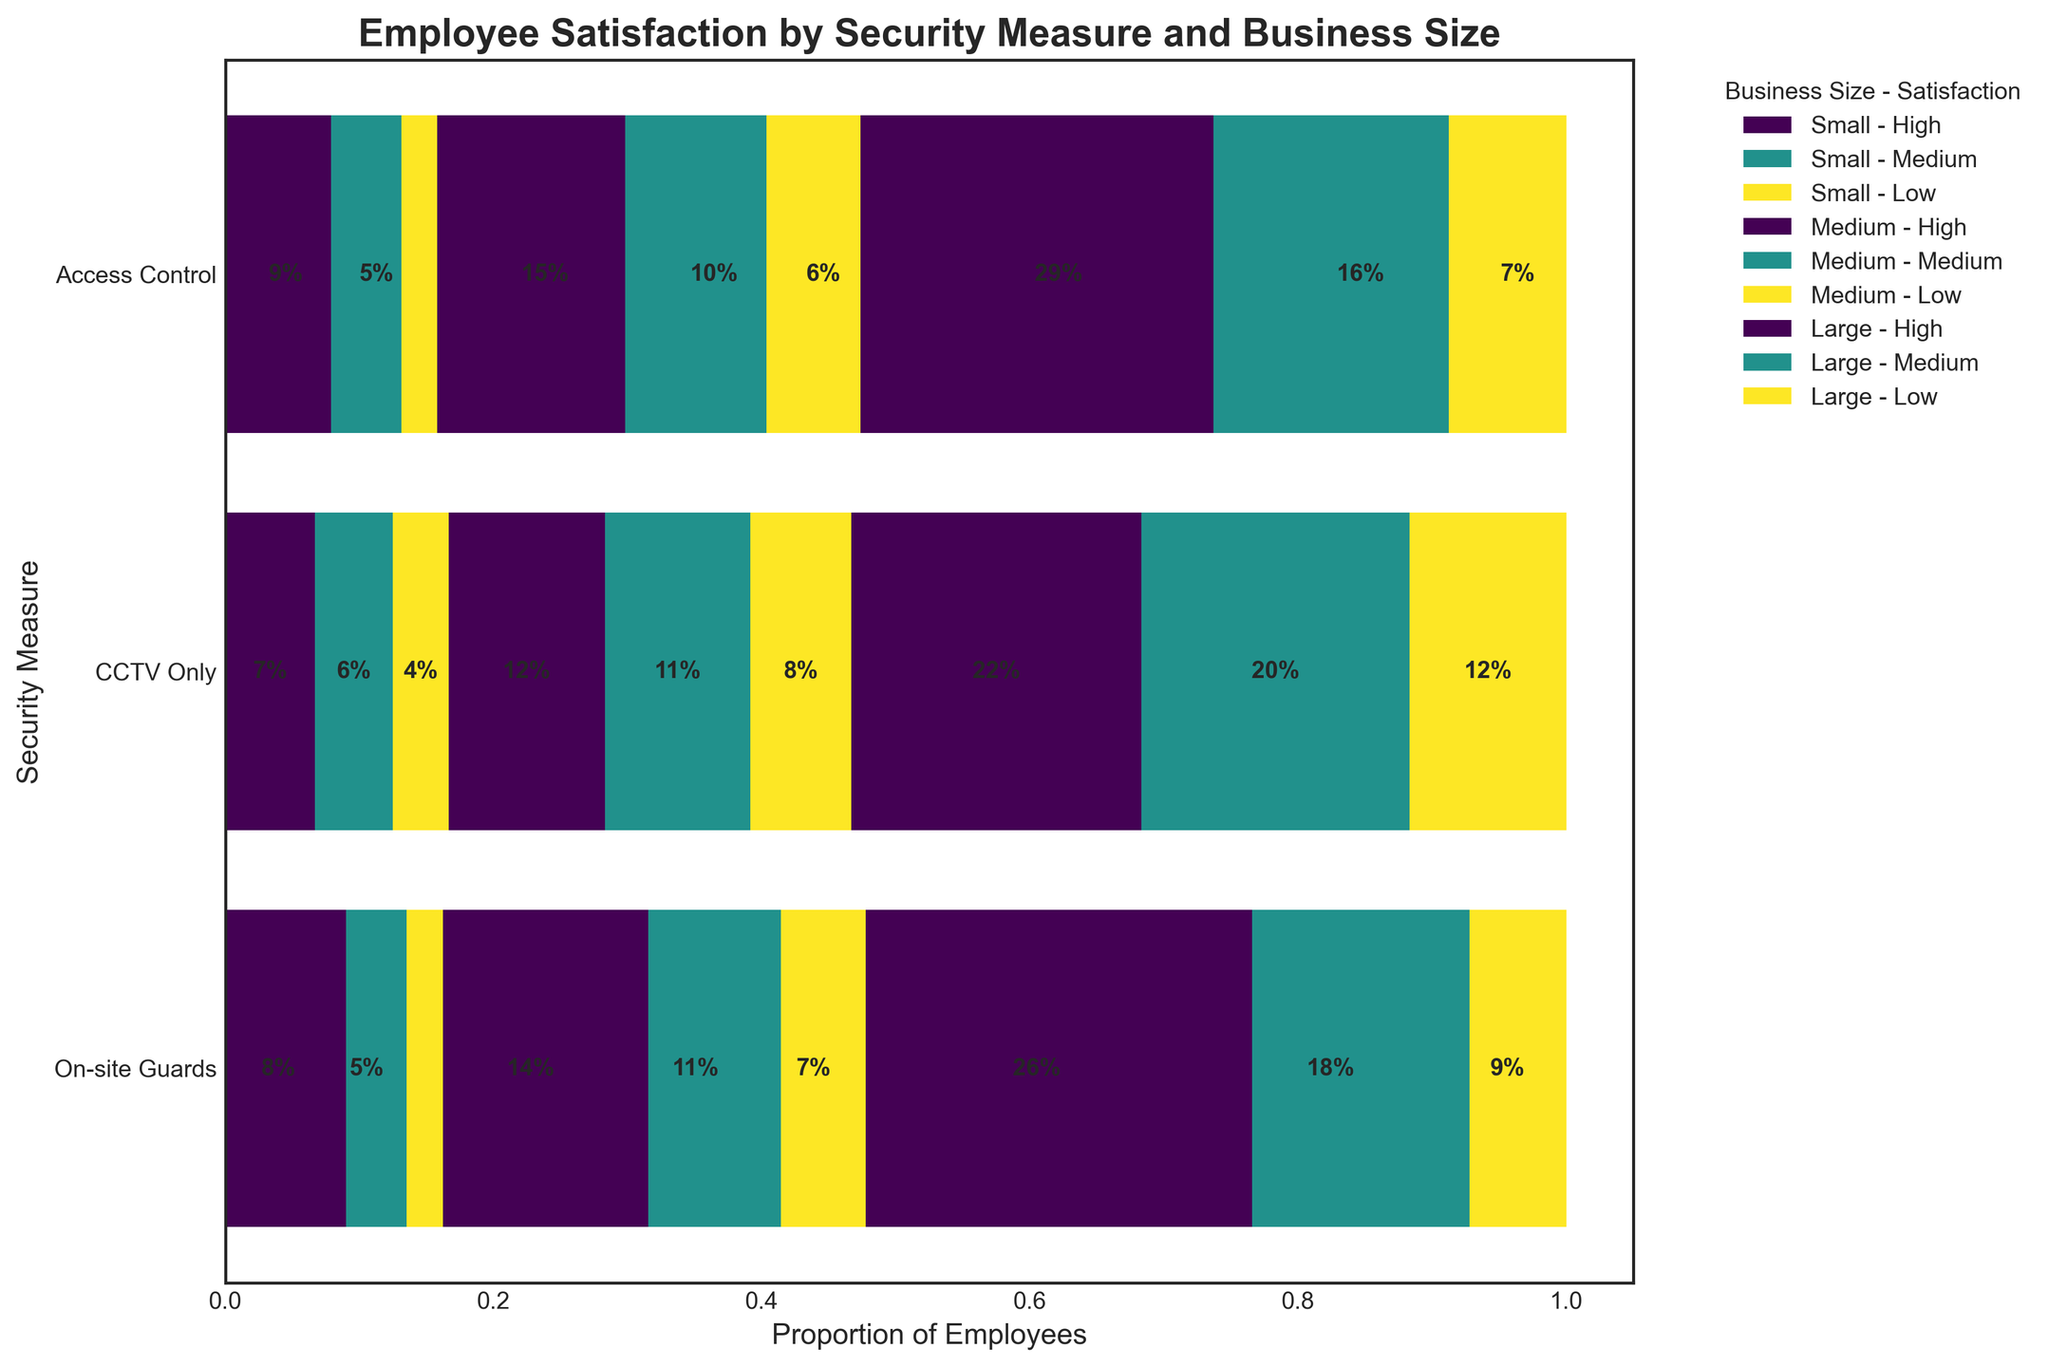What is the title of the plot? The title is located at the top of the plot, usually in a bold font. Here, it states the main purpose of the plot.
Answer: "Employee Satisfaction by Security Measure and Business Size" Which security measure has the highest proportion of employees in the "High" satisfaction level for large businesses? Look at the sections labeled for "High" satisfaction within the "Large" business segments. Identify which security measure bar has the largest segment in that category.
Answer: Access Control Which business size shows the highest proportion of employees with "Low" satisfaction for CCTV Only? Locate the "Low" satisfaction segments under the "CCTV Only" bar. Compare the sizes of these segments among different business sizes.
Answer: Large Business How does the "High" satisfaction level for small businesses compare between On-site Guards and CCTV Only security measures? Compare the "High" satisfaction segments for small businesses in the On-site Guards and CCTV Only bars.
Answer: On-site Guards: 45, CCTV Only: 40, so On-site Guards has higher proportion Among medium-sized businesses, which security measure has the lowest proportion of employees with "Low" satisfaction? Identify the "Low" satisfaction sections for medium-sized businesses and compare their sizes across security measures.
Answer: Access Control What proportion of employees in large businesses are highly satisfied with the On-site Guards security measure? Look at the "High" satisfaction section under "On-site Guards" for large businesses and note the proportion size.
Answer: 50% What is the largest satisfaction level segment within small businesses using Access Control? Locate the largest segment within the "Access Control" bar for small businesses and identify its satisfaction level.
Answer: High 